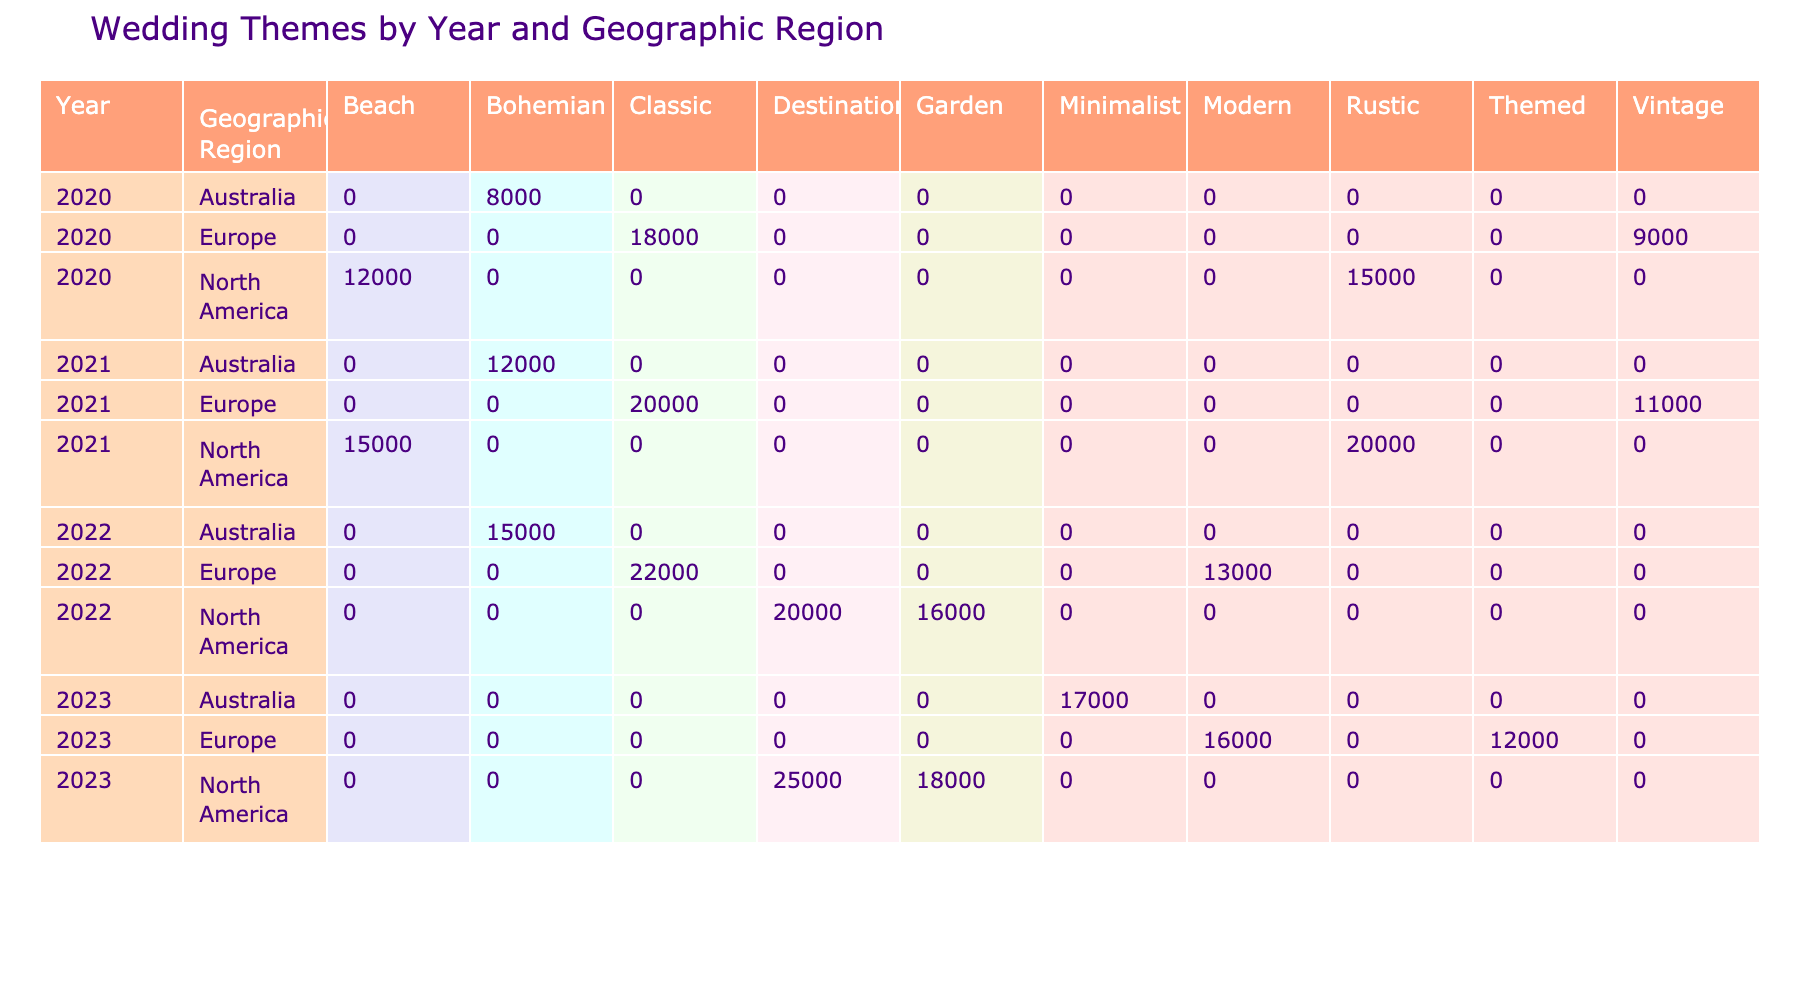What was the most popular wedding theme in North America for 2020? The table shows the number of weddings by theme in North America for 2020. The rustic theme has the highest count with 15,000 weddings, compared to the beach theme with 12,000 weddings.
Answer: Rustic How many weddings were held with a garden theme in North America from 2020 to 2023? From the table, garden-themed weddings in North America were counted as follows: 0 in 2020, 0 in 2021, 16,000 in 2022, and 18,000 in 2023. Adding these together gives 0 + 0 + 16,000 + 18,000 = 34,000 weddings.
Answer: 34,000 Is there a themed wedding in Europe recorded for 2023? Looking at the table, there is a 'Themed' wedding category listed under Europe for the year 2023. Therefore, the statement is true.
Answer: Yes Which geographic region had the highest number of weddings for the classic theme in 2022? The table reveals that in 2022, Europe had the most weddings with the classic theme, totaling 22,000. North America had 0 for that theme in 2022, so Europe is confirmed as the region with the highest number.
Answer: Europe What is the average number of weddings for the bohemian theme across all years and regions provided? The bohemian theme had 8,000 in Australia (2020), 12,000 in Australia (2021), 15,000 in Australia (2022), and 0 for 2023 in the regions mentioned. Adding these gives 8,000 + 12,000 + 15,000 + 0 = 35,000. To find the average: 35,000 divided by 3 (since there are three years accounted) equals approximately 11,667.
Answer: 11,667 How many more weddings of the beach theme were held in 2021 than in 2020 in North America? The table indicates there were 15,000 beach-themed weddings in North America in 2021 and 12,000 in 2020. The difference is 15,000 - 12,000 = 3,000 more weddings in 2021 compared to 2020.
Answer: 3,000 What was the total number of weddings in Australia for bohemian and minimalist themes combined in 2023? In the table, there are 0 bohemian weddings in 2023 and 17,000 minimalist weddings in Australia. Adding these gives 0 + 17,000 = 17,000 for Australia in 2023.
Answer: 17,000 Did the number of classic weddings in Europe increase from 2021 to 2022? The table shows that classic weddings in Europe were 20,000 in 2021 and increased to 22,000 in 2022. Thus, the number indeed increased.
Answer: Yes 